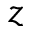Convert formula to latex. <formula><loc_0><loc_0><loc_500><loc_500>z</formula> 